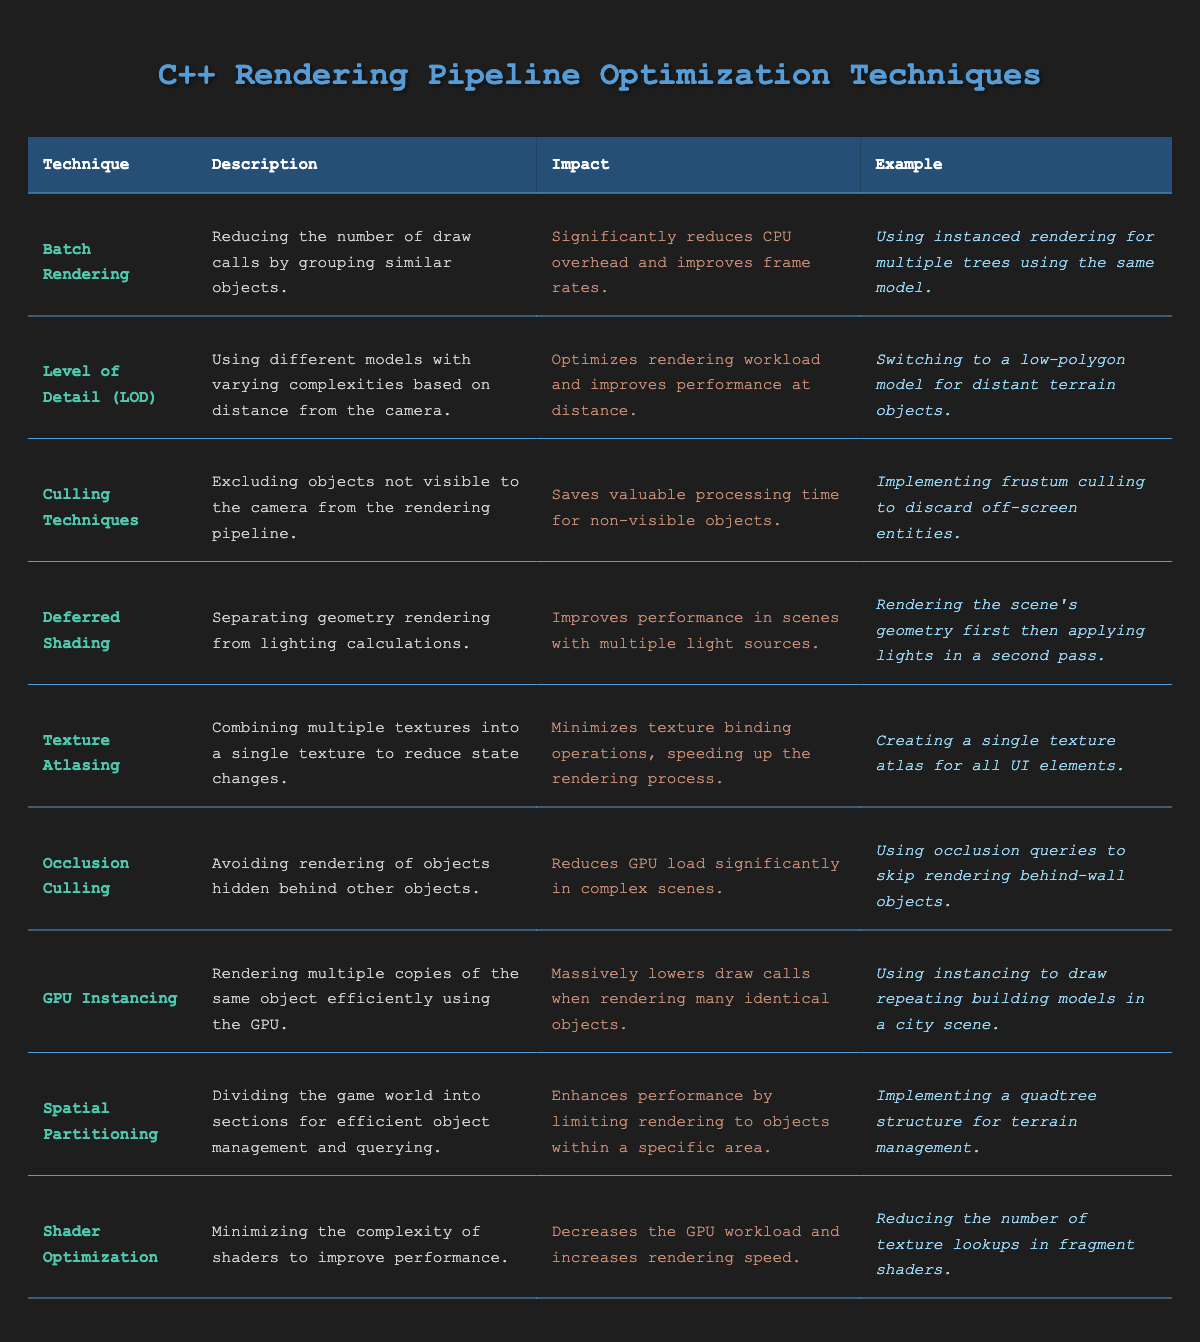What is the technique that significantly reduces CPU overhead? The table lists multiple optimization techniques, but for the one that significantly reduces CPU overhead, we can see that "Batch Rendering" is specifically mentioned in the "Impact" column.
Answer: Batch Rendering Which technique minimizes texture binding operations? Looking through the "Impact" column in the table, "Texture Atlasing" is noted for minimizing texture binding operations.
Answer: Texture Atlasing Is "Deferred Shading" used for scenes with multiple light sources? According to the table, "Deferred Shading" has an impact of improving performance in such scenes, indicating that it is indeed used for this purpose.
Answer: Yes What is the impact of using Culling Techniques? The table states that "Culling Techniques" saves valuable processing time for non-visible objects, which can be interpreted as their overall positive impact on performance.
Answer: Saves processing time Which technique would you use to avoid rendering hidden objects? The table mentions "Occlusion Culling" as the technique that specifically avoids rendering objects hidden behind others.
Answer: Occlusion Culling How many techniques involve reducing draw calls? By reviewing the table, we find both "Batch Rendering" and "GPU Instancing" mentioned under techniques that reduce draw calls. Thus, there are two techniques.
Answer: 2 What technique involves grouping similar objects? The "Batch Rendering" technique is described as reducing the number of draw calls by grouping similar objects.
Answer: Batch Rendering Are there any techniques focused on optimizing shader performance? "Shader Optimization" is explicitly listed in the table as a technique that minimizes shader complexity to improve performance, confirming there is a focus on optimizing shaders.
Answer: Yes Which two techniques improve performance by limiting rendering to specific areas? "Spatial Partitioning" and "Culling Techniques" both optimize performance by limiting what gets rendered based on visibility or area.
Answer: Spatial Partitioning and Culling Techniques What example illustrates the use of GPU Instancing? The table provides the example of using GPU Instancing to draw repeating building models in a city scene as its illustration.
Answer: Repeating building models in a city scene Which technique would be best for scenes with multiple light sources? According to the table, "Deferred Shading" is used for improving performance in scenes with multiple light sources, making it the best choice for such scenarios.
Answer: Deferred Shading 